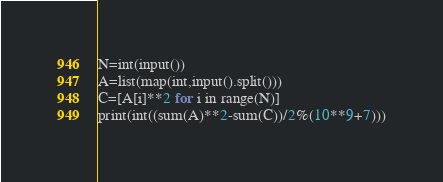Convert code to text. <code><loc_0><loc_0><loc_500><loc_500><_Python_>N=int(input())
A=list(map(int,input().split()))
C=[A[i]**2 for i in range(N)]
print(int((sum(A)**2-sum(C))/2%(10**9+7)))</code> 